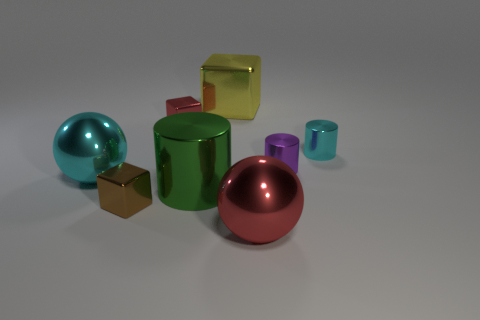Subtract all tiny metal cylinders. How many cylinders are left? 1 Subtract all cyan cylinders. How many cylinders are left? 2 Add 1 large red metallic things. How many objects exist? 9 Subtract all spheres. How many objects are left? 6 Add 8 tiny cyan metal blocks. How many tiny cyan metal blocks exist? 8 Subtract 1 purple cylinders. How many objects are left? 7 Subtract 1 cubes. How many cubes are left? 2 Subtract all gray spheres. Subtract all red blocks. How many spheres are left? 2 Subtract all red balls. How many yellow blocks are left? 1 Subtract all big yellow blocks. Subtract all large green things. How many objects are left? 6 